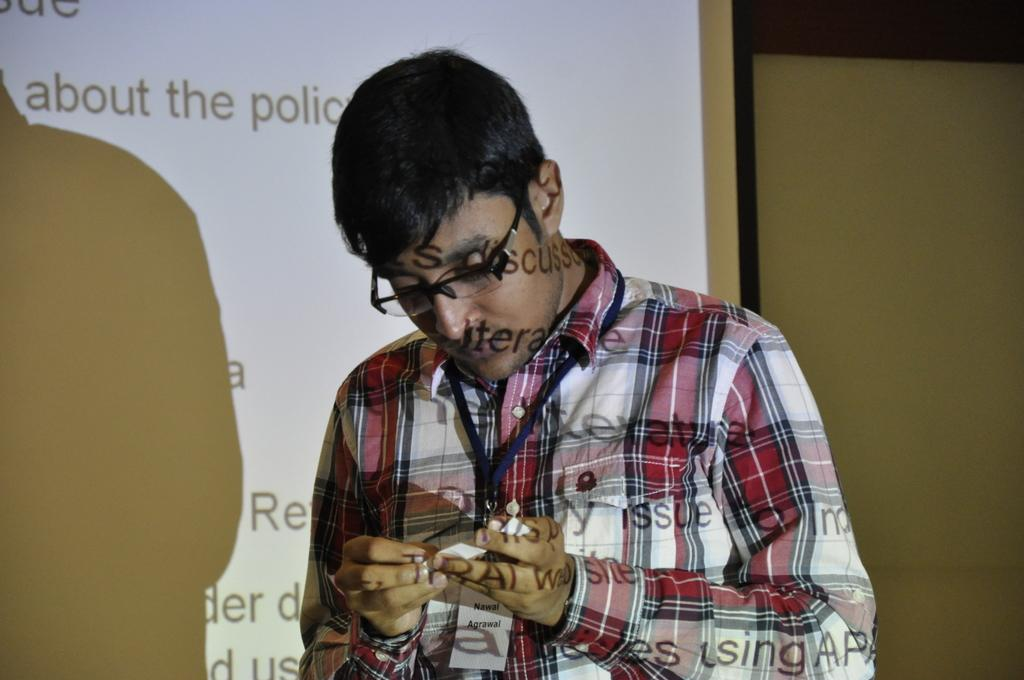Who is present in the image? There is a man in the image. What is the man wearing? The man is wearing spectacles. What is the man holding in the image? The man is holding a paper. Can you describe any visual effects in the image? There is a reflection of letters on the man's body. What can be seen in the background of the image? There is a projector screen in the background of the image. What type of soup is being served on the plastic table in the image? There is no soup or plastic table present in the image. 